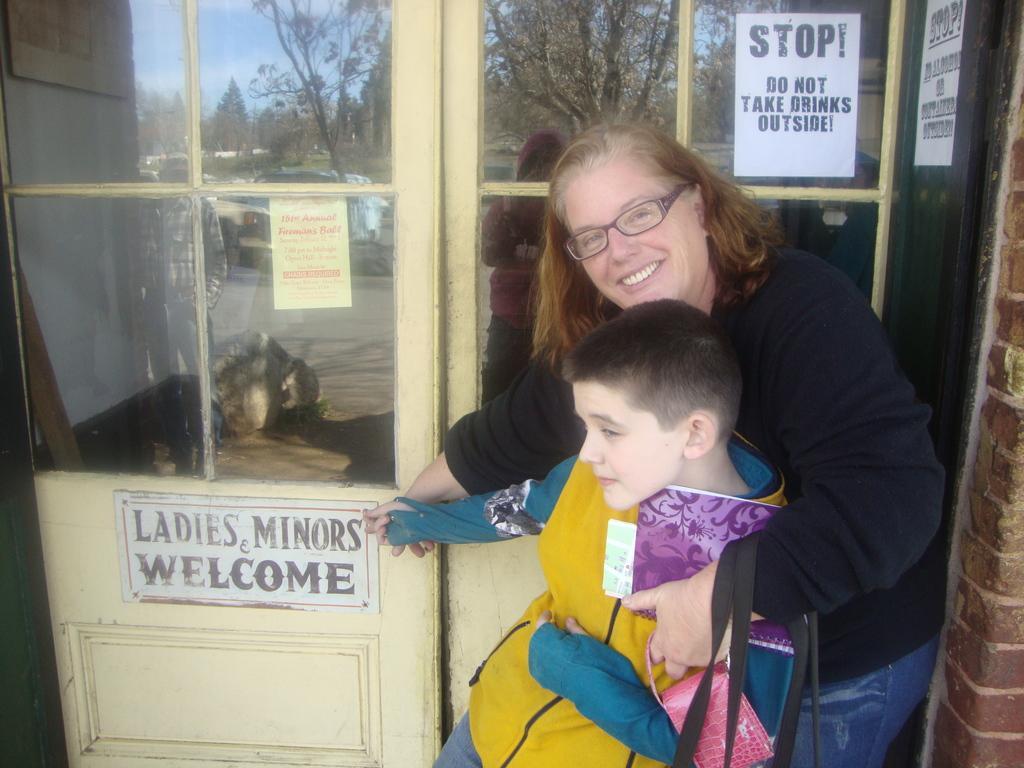Describe this image in one or two sentences. In the picture I can see a woman wearing a black color dress and spectacles is standing and smiling and we can see a child wearing a yellow color jacket is standing in front of her. In the background, I can see glass windows on which we can see posters. Here we can see the reflection of vehicles on the road, we can see people standing on the road, we can see trees and the sky in the background. 